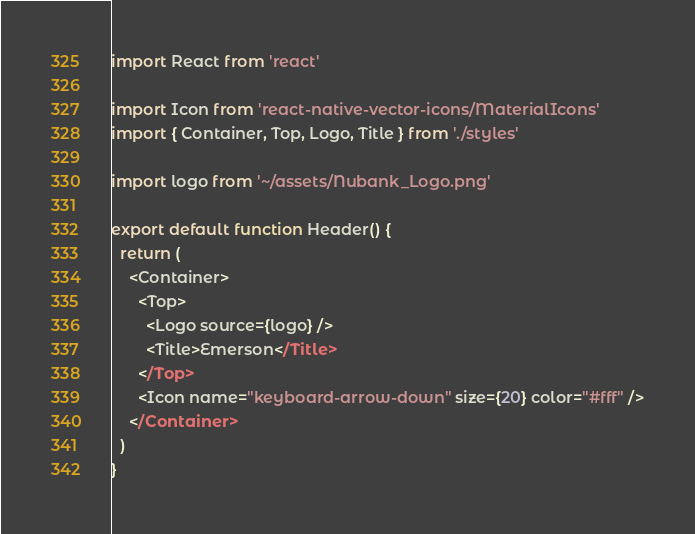Convert code to text. <code><loc_0><loc_0><loc_500><loc_500><_JavaScript_>import React from 'react'

import Icon from 'react-native-vector-icons/MaterialIcons'
import { Container, Top, Logo, Title } from './styles'

import logo from '~/assets/Nubank_Logo.png'

export default function Header() {
  return (
    <Container>
      <Top>
        <Logo source={logo} />
        <Title>Emerson</Title>
      </Top>
      <Icon name="keyboard-arrow-down" size={20} color="#fff" />
    </Container>
  )
}
</code> 